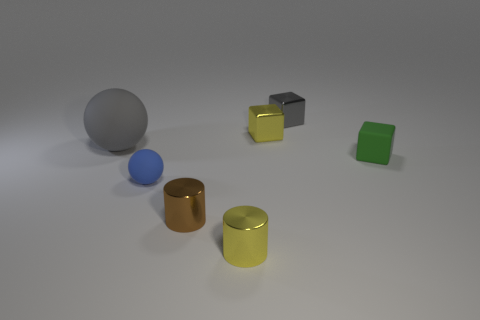Add 1 shiny cylinders. How many objects exist? 8 Subtract all balls. How many objects are left? 5 Add 7 small green matte things. How many small green matte things exist? 8 Subtract 1 brown cylinders. How many objects are left? 6 Subtract all tiny cubes. Subtract all blue objects. How many objects are left? 3 Add 3 yellow cylinders. How many yellow cylinders are left? 4 